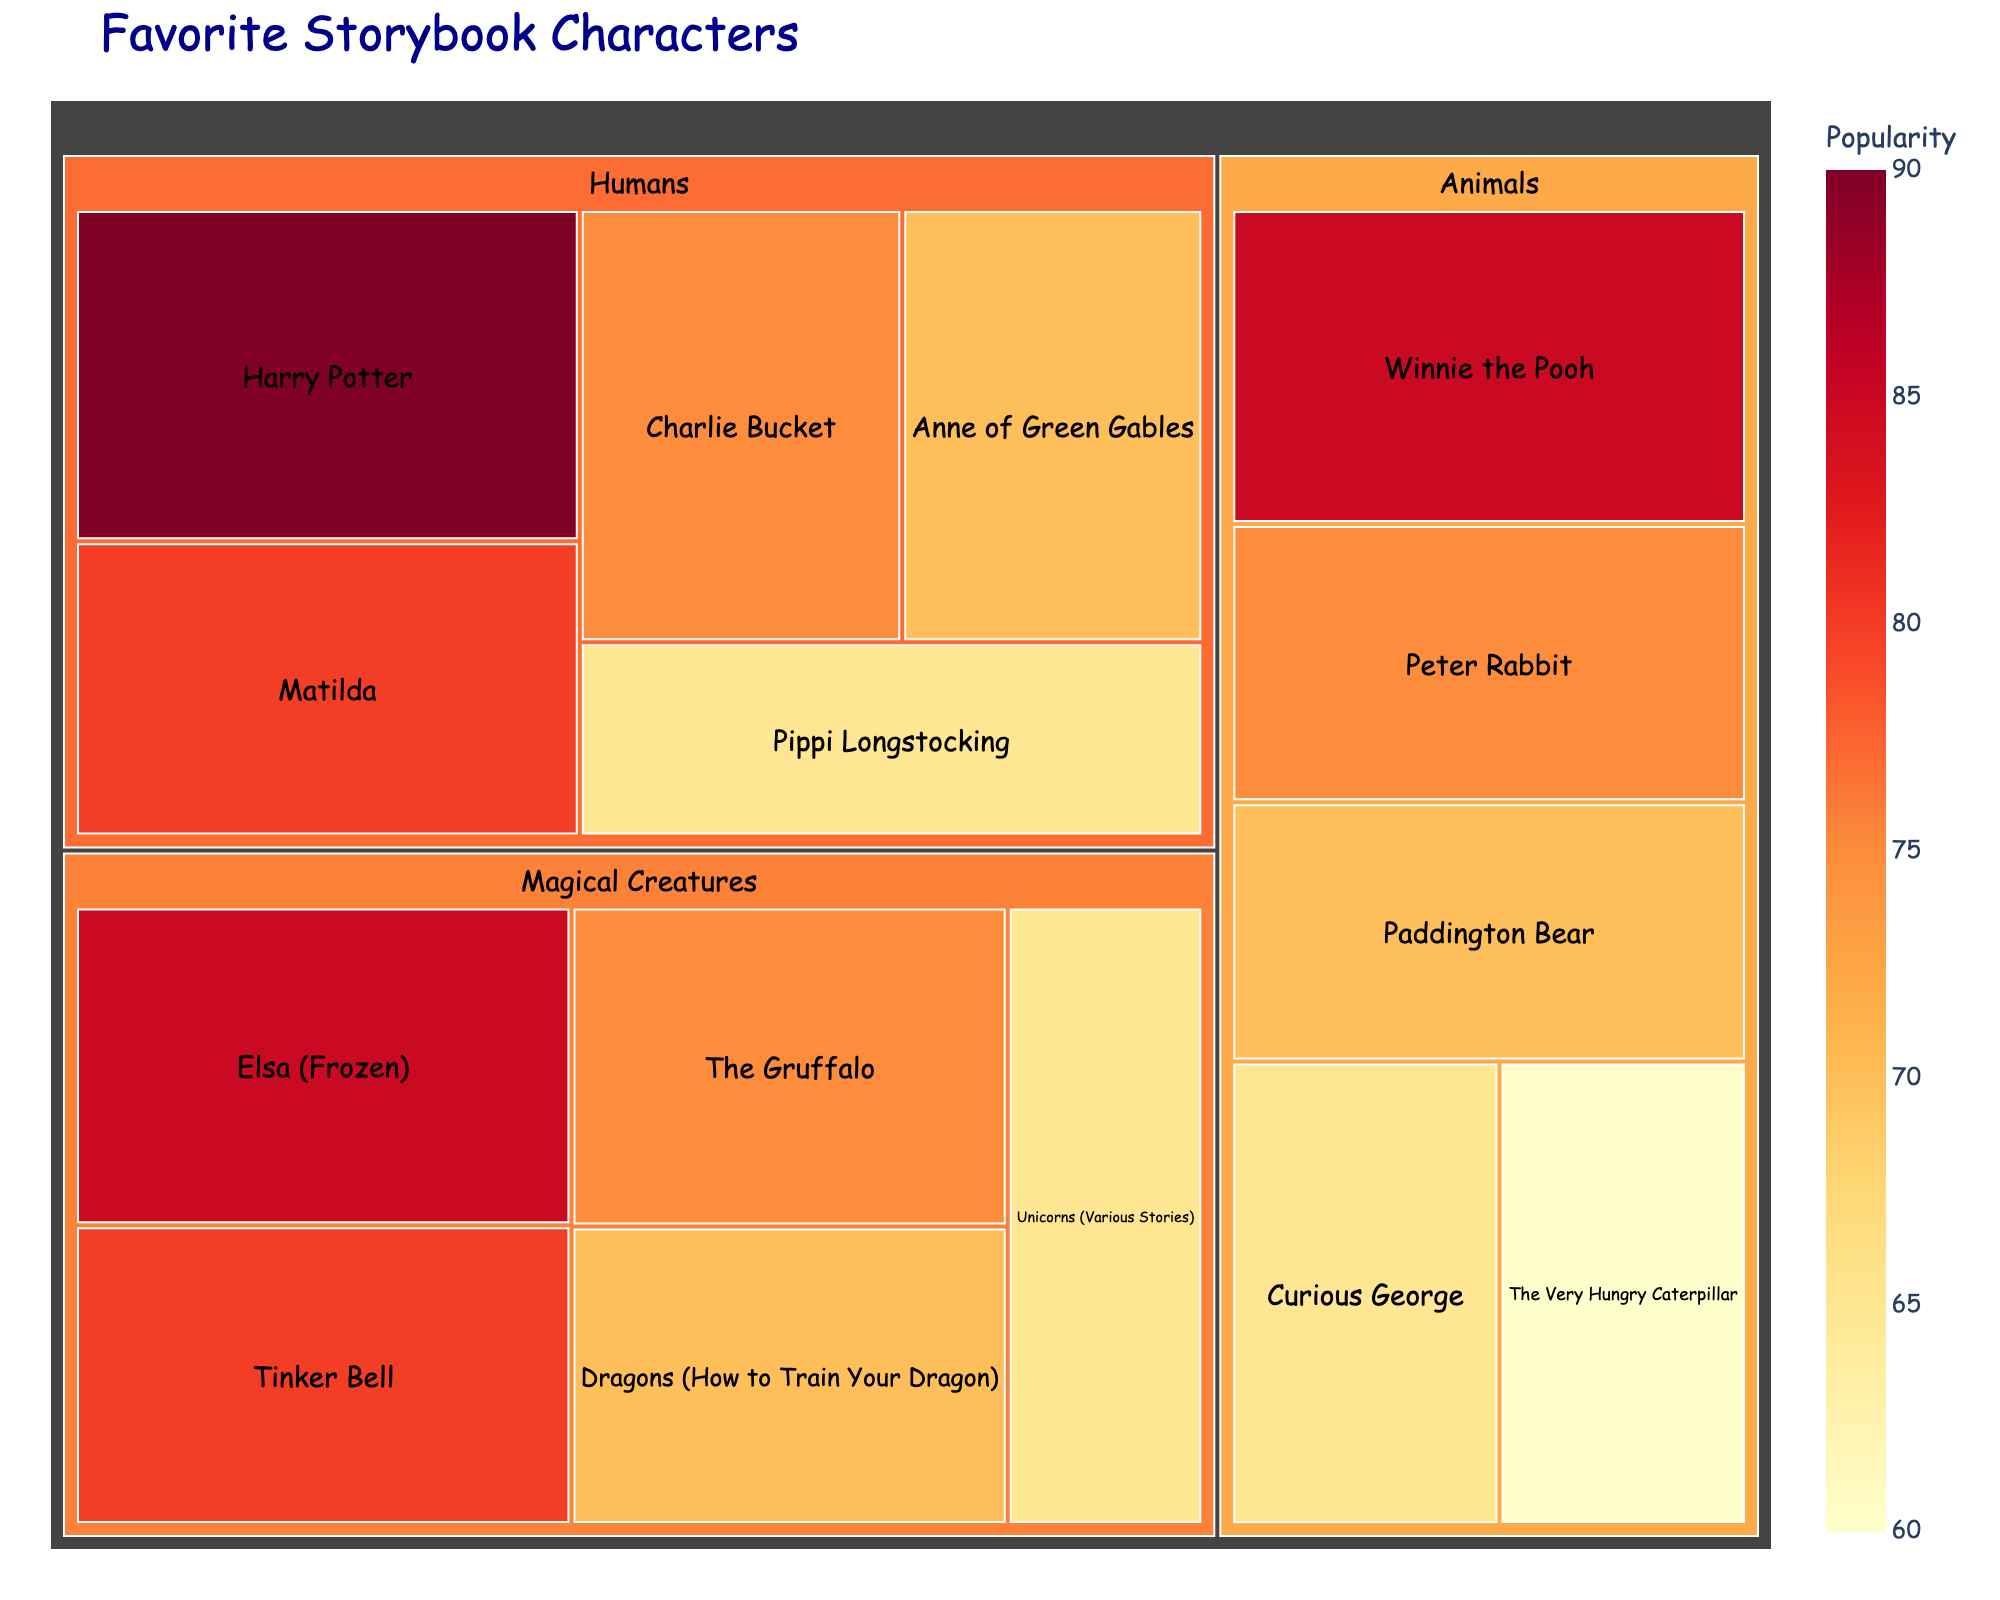What's the title of the figure? The title of the figure is usually displayed at the top of the visualization.
Answer: Favorite Storybook Characters Which category has the highest number of characters? By looking at the tree map, we can see which category has the most separate boxes representing characters.
Answer: Animals Which character is the most popular in the Humans category? In the Humans category, identify the character with the largest box or highest numerical value.
Answer: Harry Potter How many characters are in the Magical Creatures category? Count the number of separate boxes under the Magical Creatures section.
Answer: 5 Are there more characters in the Animals category or the Humans category? Compare the number of characters in the Animals category with those in the Humans category by counting the boxes in each section.
Answer: Animals What's the popularity of the least popular character among the Magical Creatures? Identify the character with the smallest value in the Magical Creatures category.
Answer: 65 What is the combined popularity of Matilda and Anne of Green Gables? Find the popularity values for both characters and add them up: Matilda (80) + Anne of Green Gables (70).
Answer: 150 Who is more popular, Winnie the Pooh or Elsa (Frozen)? Compare the popularity values between Winnie the Pooh (Animals) and Elsa (Magical Creatures).
Answer: Winnie the Pooh 